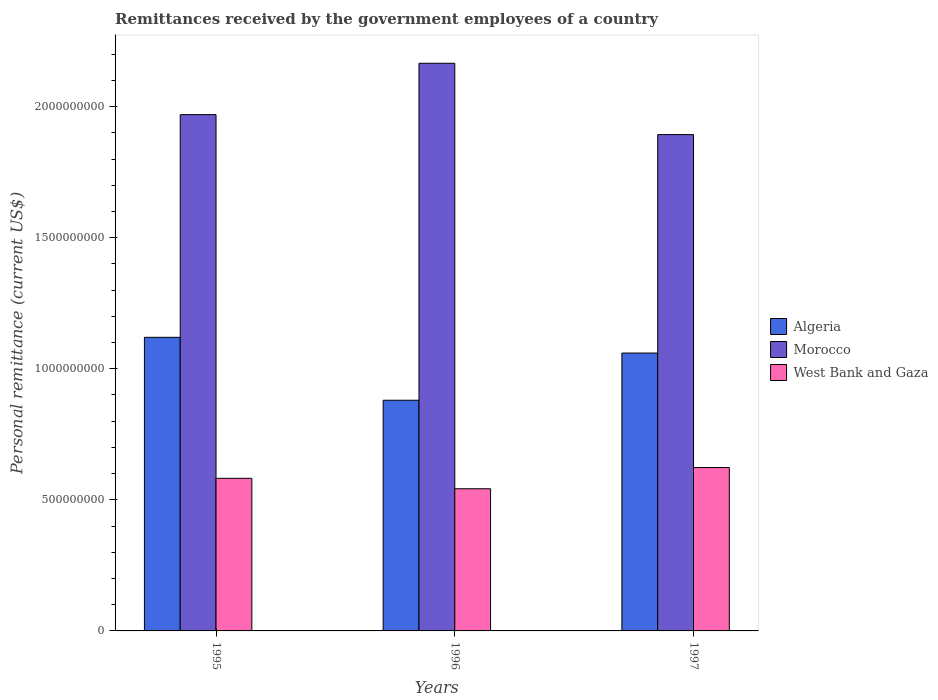How many groups of bars are there?
Keep it short and to the point. 3. How many bars are there on the 3rd tick from the right?
Give a very brief answer. 3. What is the remittances received by the government employees in West Bank and Gaza in 1997?
Your answer should be very brief. 6.23e+08. Across all years, what is the maximum remittances received by the government employees in Algeria?
Keep it short and to the point. 1.12e+09. Across all years, what is the minimum remittances received by the government employees in West Bank and Gaza?
Give a very brief answer. 5.42e+08. In which year was the remittances received by the government employees in Morocco maximum?
Keep it short and to the point. 1996. In which year was the remittances received by the government employees in Morocco minimum?
Give a very brief answer. 1997. What is the total remittances received by the government employees in Morocco in the graph?
Provide a succinct answer. 6.03e+09. What is the difference between the remittances received by the government employees in West Bank and Gaza in 1995 and that in 1996?
Offer a very short reply. 3.98e+07. What is the difference between the remittances received by the government employees in West Bank and Gaza in 1997 and the remittances received by the government employees in Algeria in 1996?
Give a very brief answer. -2.57e+08. What is the average remittances received by the government employees in West Bank and Gaza per year?
Ensure brevity in your answer.  5.83e+08. In the year 1997, what is the difference between the remittances received by the government employees in West Bank and Gaza and remittances received by the government employees in Algeria?
Make the answer very short. -4.37e+08. In how many years, is the remittances received by the government employees in Algeria greater than 200000000 US$?
Keep it short and to the point. 3. What is the ratio of the remittances received by the government employees in West Bank and Gaza in 1995 to that in 1996?
Provide a succinct answer. 1.07. What is the difference between the highest and the second highest remittances received by the government employees in Morocco?
Your answer should be very brief. 1.96e+08. What is the difference between the highest and the lowest remittances received by the government employees in Algeria?
Make the answer very short. 2.40e+08. Is the sum of the remittances received by the government employees in West Bank and Gaza in 1995 and 1996 greater than the maximum remittances received by the government employees in Morocco across all years?
Your answer should be very brief. No. What does the 3rd bar from the left in 1995 represents?
Give a very brief answer. West Bank and Gaza. What does the 3rd bar from the right in 1996 represents?
Your answer should be very brief. Algeria. Is it the case that in every year, the sum of the remittances received by the government employees in Algeria and remittances received by the government employees in West Bank and Gaza is greater than the remittances received by the government employees in Morocco?
Your answer should be compact. No. Are all the bars in the graph horizontal?
Offer a very short reply. No. Where does the legend appear in the graph?
Ensure brevity in your answer.  Center right. What is the title of the graph?
Provide a succinct answer. Remittances received by the government employees of a country. Does "Slovak Republic" appear as one of the legend labels in the graph?
Ensure brevity in your answer.  No. What is the label or title of the X-axis?
Provide a short and direct response. Years. What is the label or title of the Y-axis?
Ensure brevity in your answer.  Personal remittance (current US$). What is the Personal remittance (current US$) of Algeria in 1995?
Provide a short and direct response. 1.12e+09. What is the Personal remittance (current US$) of Morocco in 1995?
Make the answer very short. 1.97e+09. What is the Personal remittance (current US$) of West Bank and Gaza in 1995?
Your answer should be compact. 5.82e+08. What is the Personal remittance (current US$) in Algeria in 1996?
Provide a short and direct response. 8.80e+08. What is the Personal remittance (current US$) in Morocco in 1996?
Keep it short and to the point. 2.17e+09. What is the Personal remittance (current US$) in West Bank and Gaza in 1996?
Provide a succinct answer. 5.42e+08. What is the Personal remittance (current US$) in Algeria in 1997?
Offer a very short reply. 1.06e+09. What is the Personal remittance (current US$) of Morocco in 1997?
Make the answer very short. 1.89e+09. What is the Personal remittance (current US$) of West Bank and Gaza in 1997?
Your response must be concise. 6.23e+08. Across all years, what is the maximum Personal remittance (current US$) in Algeria?
Make the answer very short. 1.12e+09. Across all years, what is the maximum Personal remittance (current US$) in Morocco?
Make the answer very short. 2.17e+09. Across all years, what is the maximum Personal remittance (current US$) in West Bank and Gaza?
Your response must be concise. 6.23e+08. Across all years, what is the minimum Personal remittance (current US$) of Algeria?
Keep it short and to the point. 8.80e+08. Across all years, what is the minimum Personal remittance (current US$) of Morocco?
Your response must be concise. 1.89e+09. Across all years, what is the minimum Personal remittance (current US$) in West Bank and Gaza?
Keep it short and to the point. 5.42e+08. What is the total Personal remittance (current US$) of Algeria in the graph?
Offer a very short reply. 3.06e+09. What is the total Personal remittance (current US$) in Morocco in the graph?
Provide a short and direct response. 6.03e+09. What is the total Personal remittance (current US$) of West Bank and Gaza in the graph?
Your answer should be very brief. 1.75e+09. What is the difference between the Personal remittance (current US$) in Algeria in 1995 and that in 1996?
Make the answer very short. 2.40e+08. What is the difference between the Personal remittance (current US$) in Morocco in 1995 and that in 1996?
Make the answer very short. -1.96e+08. What is the difference between the Personal remittance (current US$) in West Bank and Gaza in 1995 and that in 1996?
Provide a succinct answer. 3.98e+07. What is the difference between the Personal remittance (current US$) of Algeria in 1995 and that in 1997?
Provide a short and direct response. 6.00e+07. What is the difference between the Personal remittance (current US$) in Morocco in 1995 and that in 1997?
Your answer should be compact. 7.62e+07. What is the difference between the Personal remittance (current US$) in West Bank and Gaza in 1995 and that in 1997?
Your response must be concise. -4.12e+07. What is the difference between the Personal remittance (current US$) in Algeria in 1996 and that in 1997?
Provide a short and direct response. -1.80e+08. What is the difference between the Personal remittance (current US$) of Morocco in 1996 and that in 1997?
Your answer should be very brief. 2.72e+08. What is the difference between the Personal remittance (current US$) of West Bank and Gaza in 1996 and that in 1997?
Keep it short and to the point. -8.10e+07. What is the difference between the Personal remittance (current US$) in Algeria in 1995 and the Personal remittance (current US$) in Morocco in 1996?
Make the answer very short. -1.05e+09. What is the difference between the Personal remittance (current US$) of Algeria in 1995 and the Personal remittance (current US$) of West Bank and Gaza in 1996?
Your answer should be very brief. 5.78e+08. What is the difference between the Personal remittance (current US$) of Morocco in 1995 and the Personal remittance (current US$) of West Bank and Gaza in 1996?
Keep it short and to the point. 1.43e+09. What is the difference between the Personal remittance (current US$) of Algeria in 1995 and the Personal remittance (current US$) of Morocco in 1997?
Your response must be concise. -7.73e+08. What is the difference between the Personal remittance (current US$) in Algeria in 1995 and the Personal remittance (current US$) in West Bank and Gaza in 1997?
Your answer should be compact. 4.97e+08. What is the difference between the Personal remittance (current US$) of Morocco in 1995 and the Personal remittance (current US$) of West Bank and Gaza in 1997?
Your answer should be very brief. 1.35e+09. What is the difference between the Personal remittance (current US$) of Algeria in 1996 and the Personal remittance (current US$) of Morocco in 1997?
Provide a short and direct response. -1.01e+09. What is the difference between the Personal remittance (current US$) in Algeria in 1996 and the Personal remittance (current US$) in West Bank and Gaza in 1997?
Offer a terse response. 2.57e+08. What is the difference between the Personal remittance (current US$) of Morocco in 1996 and the Personal remittance (current US$) of West Bank and Gaza in 1997?
Offer a terse response. 1.54e+09. What is the average Personal remittance (current US$) of Algeria per year?
Your answer should be compact. 1.02e+09. What is the average Personal remittance (current US$) in Morocco per year?
Give a very brief answer. 2.01e+09. What is the average Personal remittance (current US$) of West Bank and Gaza per year?
Make the answer very short. 5.83e+08. In the year 1995, what is the difference between the Personal remittance (current US$) in Algeria and Personal remittance (current US$) in Morocco?
Provide a short and direct response. -8.50e+08. In the year 1995, what is the difference between the Personal remittance (current US$) in Algeria and Personal remittance (current US$) in West Bank and Gaza?
Your response must be concise. 5.38e+08. In the year 1995, what is the difference between the Personal remittance (current US$) in Morocco and Personal remittance (current US$) in West Bank and Gaza?
Ensure brevity in your answer.  1.39e+09. In the year 1996, what is the difference between the Personal remittance (current US$) of Algeria and Personal remittance (current US$) of Morocco?
Offer a terse response. -1.29e+09. In the year 1996, what is the difference between the Personal remittance (current US$) in Algeria and Personal remittance (current US$) in West Bank and Gaza?
Make the answer very short. 3.38e+08. In the year 1996, what is the difference between the Personal remittance (current US$) of Morocco and Personal remittance (current US$) of West Bank and Gaza?
Your answer should be compact. 1.62e+09. In the year 1997, what is the difference between the Personal remittance (current US$) of Algeria and Personal remittance (current US$) of Morocco?
Your answer should be very brief. -8.33e+08. In the year 1997, what is the difference between the Personal remittance (current US$) in Algeria and Personal remittance (current US$) in West Bank and Gaza?
Keep it short and to the point. 4.37e+08. In the year 1997, what is the difference between the Personal remittance (current US$) in Morocco and Personal remittance (current US$) in West Bank and Gaza?
Your answer should be very brief. 1.27e+09. What is the ratio of the Personal remittance (current US$) of Algeria in 1995 to that in 1996?
Offer a terse response. 1.27. What is the ratio of the Personal remittance (current US$) in Morocco in 1995 to that in 1996?
Ensure brevity in your answer.  0.91. What is the ratio of the Personal remittance (current US$) of West Bank and Gaza in 1995 to that in 1996?
Offer a terse response. 1.07. What is the ratio of the Personal remittance (current US$) of Algeria in 1995 to that in 1997?
Give a very brief answer. 1.06. What is the ratio of the Personal remittance (current US$) of Morocco in 1995 to that in 1997?
Offer a very short reply. 1.04. What is the ratio of the Personal remittance (current US$) in West Bank and Gaza in 1995 to that in 1997?
Your answer should be very brief. 0.93. What is the ratio of the Personal remittance (current US$) in Algeria in 1996 to that in 1997?
Give a very brief answer. 0.83. What is the ratio of the Personal remittance (current US$) of Morocco in 1996 to that in 1997?
Ensure brevity in your answer.  1.14. What is the ratio of the Personal remittance (current US$) in West Bank and Gaza in 1996 to that in 1997?
Your answer should be very brief. 0.87. What is the difference between the highest and the second highest Personal remittance (current US$) of Algeria?
Provide a short and direct response. 6.00e+07. What is the difference between the highest and the second highest Personal remittance (current US$) of Morocco?
Offer a very short reply. 1.96e+08. What is the difference between the highest and the second highest Personal remittance (current US$) in West Bank and Gaza?
Offer a very short reply. 4.12e+07. What is the difference between the highest and the lowest Personal remittance (current US$) in Algeria?
Ensure brevity in your answer.  2.40e+08. What is the difference between the highest and the lowest Personal remittance (current US$) of Morocco?
Your answer should be compact. 2.72e+08. What is the difference between the highest and the lowest Personal remittance (current US$) in West Bank and Gaza?
Offer a very short reply. 8.10e+07. 